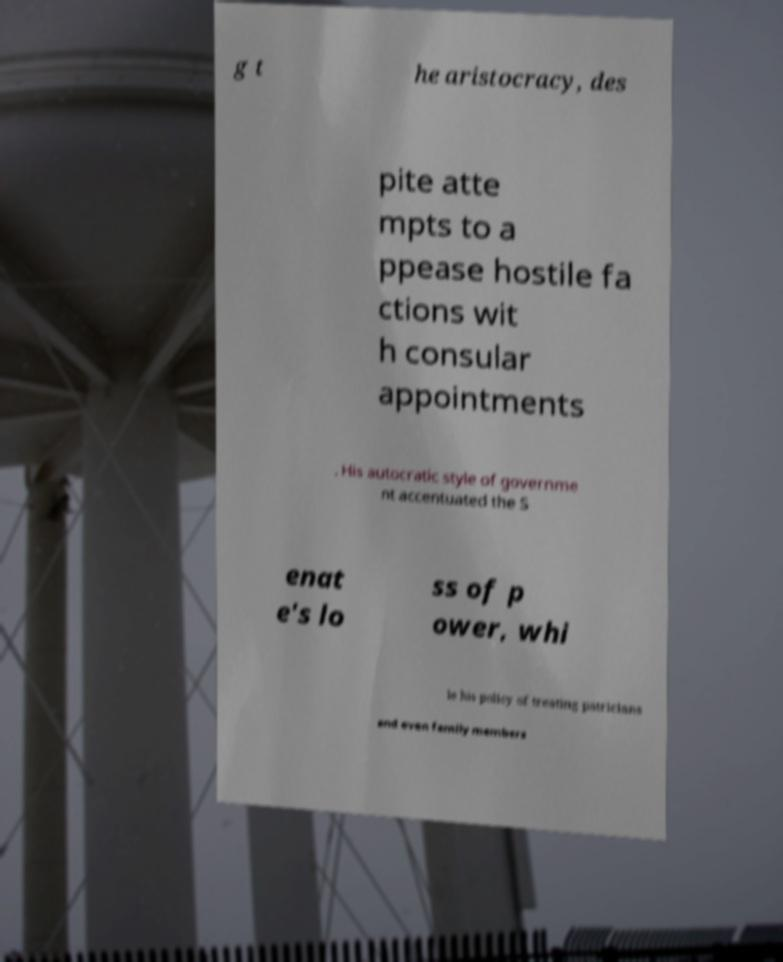Could you extract and type out the text from this image? g t he aristocracy, des pite atte mpts to a ppease hostile fa ctions wit h consular appointments . His autocratic style of governme nt accentuated the S enat e's lo ss of p ower, whi le his policy of treating patricians and even family members 